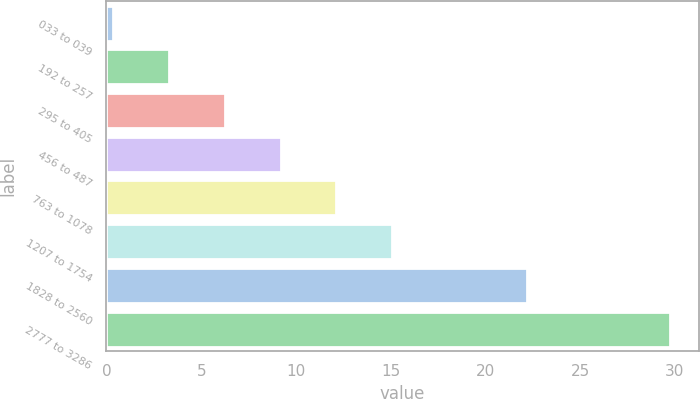<chart> <loc_0><loc_0><loc_500><loc_500><bar_chart><fcel>033 to 039<fcel>192 to 257<fcel>295 to 405<fcel>456 to 487<fcel>763 to 1078<fcel>1207 to 1754<fcel>1828 to 2560<fcel>2777 to 3286<nl><fcel>0.37<fcel>3.31<fcel>6.25<fcel>9.19<fcel>12.13<fcel>15.07<fcel>22.18<fcel>29.76<nl></chart> 